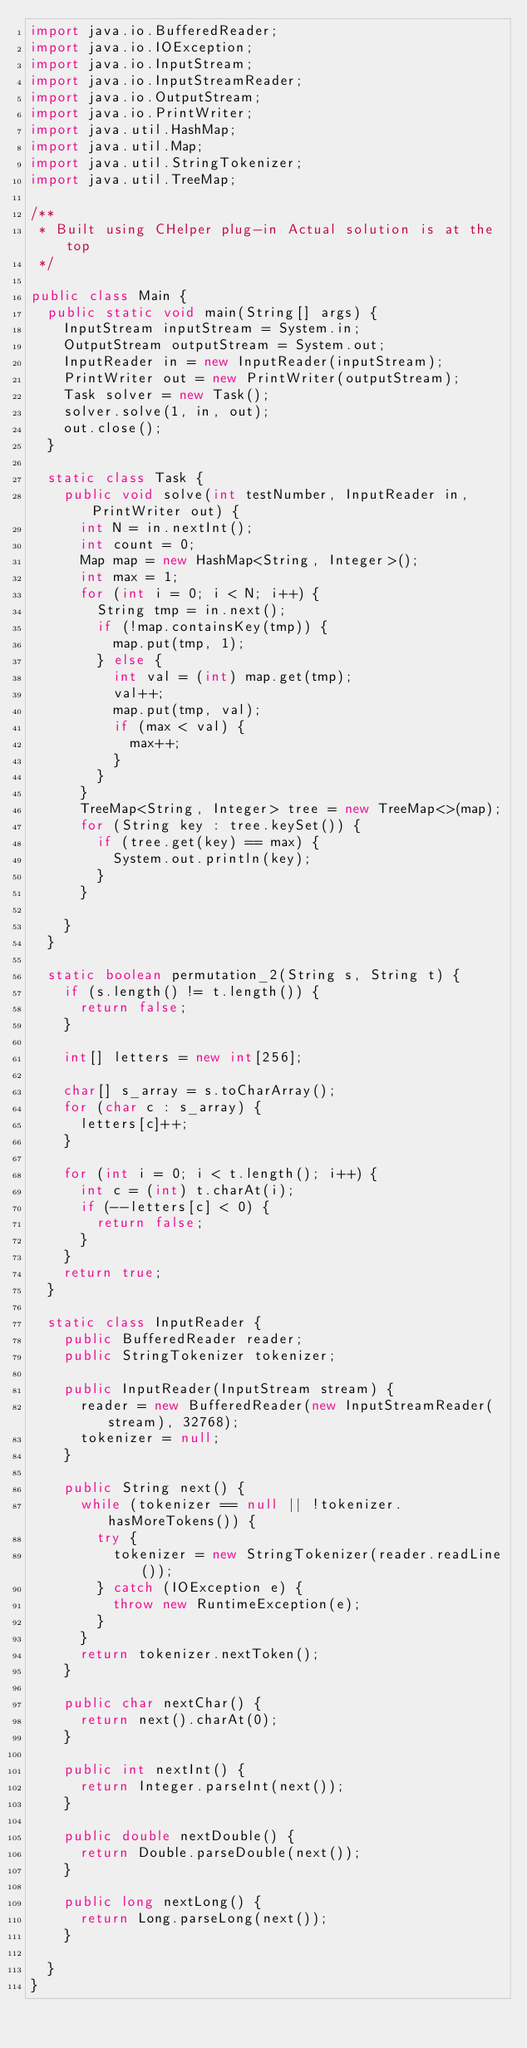<code> <loc_0><loc_0><loc_500><loc_500><_Java_>import java.io.BufferedReader;
import java.io.IOException;
import java.io.InputStream;
import java.io.InputStreamReader;
import java.io.OutputStream;
import java.io.PrintWriter;
import java.util.HashMap;
import java.util.Map;
import java.util.StringTokenizer;
import java.util.TreeMap;

/**
 * Built using CHelper plug-in Actual solution is at the top
 */

public class Main {
	public static void main(String[] args) {
		InputStream inputStream = System.in;
		OutputStream outputStream = System.out;
		InputReader in = new InputReader(inputStream);
		PrintWriter out = new PrintWriter(outputStream);
		Task solver = new Task();
		solver.solve(1, in, out);
		out.close();
	}

	static class Task {
		public void solve(int testNumber, InputReader in, PrintWriter out) {
			int N = in.nextInt();
			int count = 0;
			Map map = new HashMap<String, Integer>();
			int max = 1;
			for (int i = 0; i < N; i++) {
				String tmp = in.next();
				if (!map.containsKey(tmp)) {
					map.put(tmp, 1);
				} else {
					int val = (int) map.get(tmp);
					val++;
					map.put(tmp, val);
					if (max < val) {
						max++;
					}
				}
			}
			TreeMap<String, Integer> tree = new TreeMap<>(map);
			for (String key : tree.keySet()) {
				if (tree.get(key) == max) {
					System.out.println(key);
				}
			}

		}
	}

	static boolean permutation_2(String s, String t) {
		if (s.length() != t.length()) {
			return false;
		}

		int[] letters = new int[256];

		char[] s_array = s.toCharArray();
		for (char c : s_array) {
			letters[c]++;
		}

		for (int i = 0; i < t.length(); i++) {
			int c = (int) t.charAt(i);
			if (--letters[c] < 0) {
				return false;
			}
		}
		return true;
	}

	static class InputReader {
		public BufferedReader reader;
		public StringTokenizer tokenizer;

		public InputReader(InputStream stream) {
			reader = new BufferedReader(new InputStreamReader(stream), 32768);
			tokenizer = null;
		}

		public String next() {
			while (tokenizer == null || !tokenizer.hasMoreTokens()) {
				try {
					tokenizer = new StringTokenizer(reader.readLine());
				} catch (IOException e) {
					throw new RuntimeException(e);
				}
			}
			return tokenizer.nextToken();
		}

		public char nextChar() {
			return next().charAt(0);
		}

		public int nextInt() {
			return Integer.parseInt(next());
		}

		public double nextDouble() {
			return Double.parseDouble(next());
		}

		public long nextLong() {
			return Long.parseLong(next());
		}

	}
}
</code> 